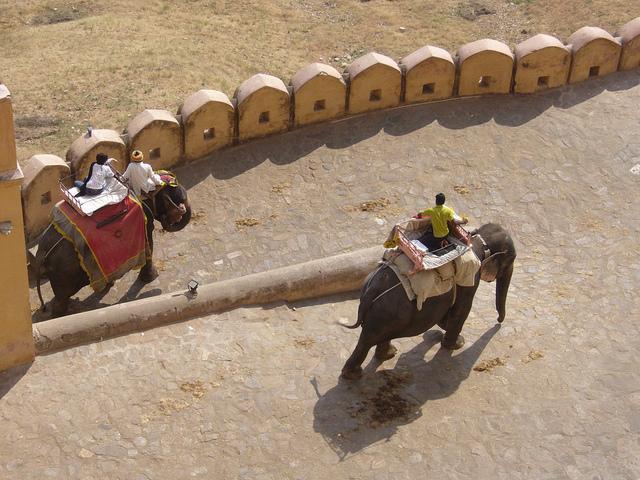How many elephants are in the picture?
Give a very brief answer. 2. 